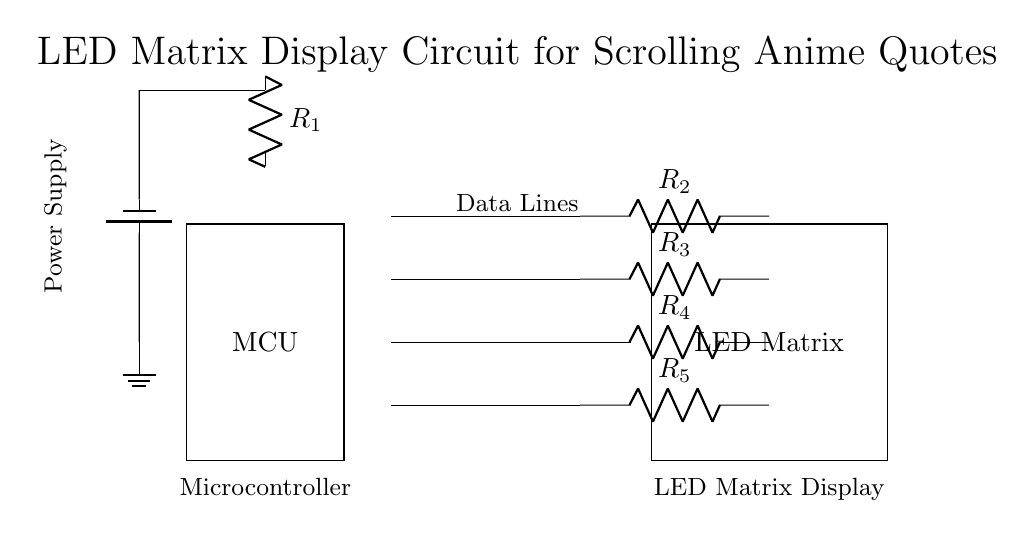What is the main component controlling the LED matrix? The microcontroller (MCU) is the main component managing and controlling the LED matrix display by sending the necessary data signals.
Answer: MCU How many resistors are present in the circuit? There are five resistors labeled R1, R2, R3, R4, and R5, which are used to limit the current flowing to the LED matrix.
Answer: 5 What is the purpose of the power supply in this circuit? The power supply provides the necessary voltage and current for the entire circuit, allowing the microcontroller and LED matrix to operate effectively.
Answer: Voltage supply What is the relationship between the microcontroller and the LED matrix? The microcontroller sends signals through data lines to control the LEDs in the matrix, allowing for the display of scrolling anime quotes.
Answer: Control signals What type of power supply is used in this circuit? The circuit uses a battery as its power supply, which is indicated by the symbol for the battery in the diagram.
Answer: Battery Which component is responsible for limiting the current to the LED matrix? The resistors R2, R3, R4, and R5 are each limiting the current to different rows in the LED matrix, to prevent damage from excessive current flow.
Answer: Resistors How does the power supply connect to the rest of the circuit? The power supply connects to the microcontroller and the resistors, which subsequently connect to the LED matrix, providing power to the circuit as a whole.
Answer: Series connection 